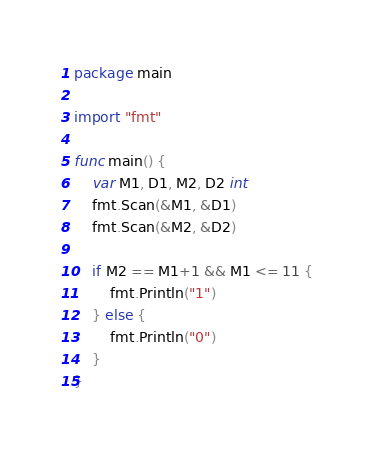<code> <loc_0><loc_0><loc_500><loc_500><_Go_>package main

import "fmt"

func main() {
	var M1, D1, M2, D2 int
	fmt.Scan(&M1, &D1)
	fmt.Scan(&M2, &D2)

	if M2 == M1+1 && M1 <= 11 {
		fmt.Println("1")
	} else {
		fmt.Println("0")
	}
}
</code> 